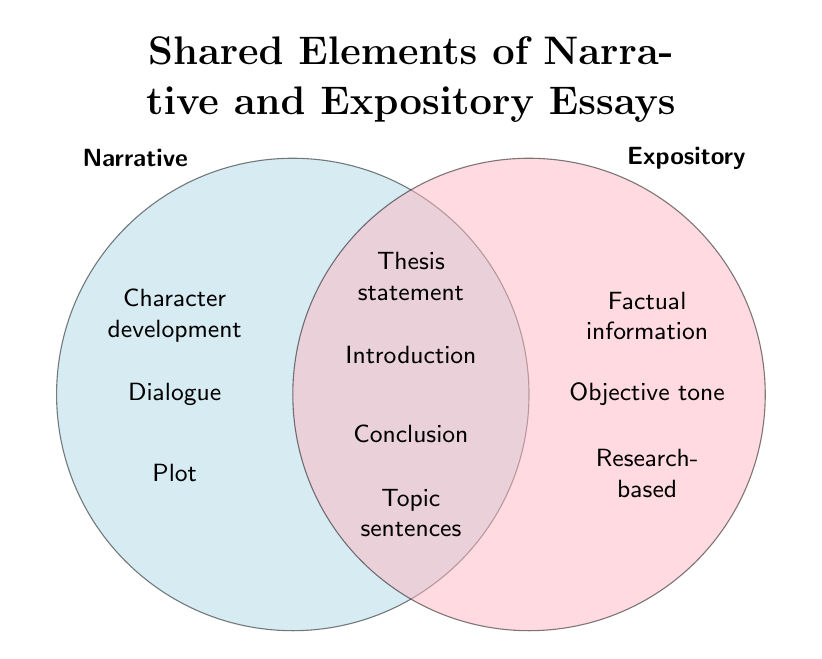What is the title of the figure? The title is written at the top of the figure in a larger, bold font.
Answer: Shared Elements of Narrative and Expository Essays Which essay type has "Character development"? By looking at the labels and their placements, "Character development" is placed under the Narrative section on the left.
Answer: Narrative Name one element that is shared between narrative and expository essays. Shared elements are placed where the two circles overlap. One such element is "Thesis statement."
Answer: Thesis statement Which section has more unique elements listed, Narrative or Expository? The left section (Narrative) has 4 unique elements while the right section (Expository) has 4 unique elements. They have the same number of unique elements.
Answer: Equal How many elements are listed in the intersection of the two circles? You can count the elements listed in the overlapping area where elements are combined.
Answer: 4 Can you name an element that appears exclusively in the Expository section? Exclusive elements can be found only in one specific circle. One such element in the Expository section is "Factual information."
Answer: Factual information What types of sentences are shared between narrative and expository essays? By identifying the common elements, "Topic sentences" is found in the overlapping area of the two types of essays.
Answer: Topic sentences Identify the elements present in both essay types that are placed at the beginning and end of the essays. The elements in the intersection that can be found at the beginning and end of essays are "Introduction" and "Conclusion."
Answer: Introduction and Conclusion Which type of essay likely uses more descriptive language? Looking at the unique elements, "Descriptive language" is listed under the Narrative section.
Answer: Narrative Would a thesis statement be found in a narrative essay? The element "Thesis statement" is found in the shared area, meaning it appears in both Narrative and Expository essays.
Answer: Yes 